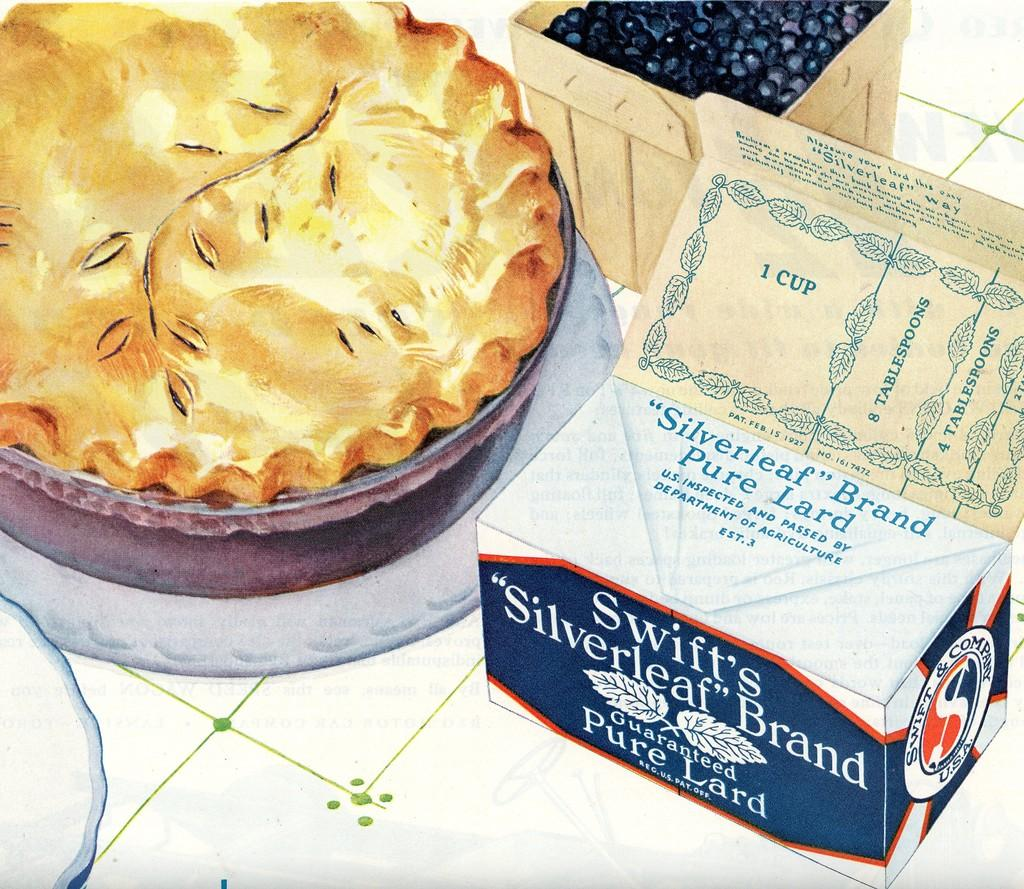What is on the plate in the image? There is food in a plate in the image. What objects can be seen on the floor in the image? There is a paper box and a wooden box on the floor in the image. What type of voice can be heard coming from the food in the image? There is no voice present in the image, as it is a still image and not a video or audio recording. 